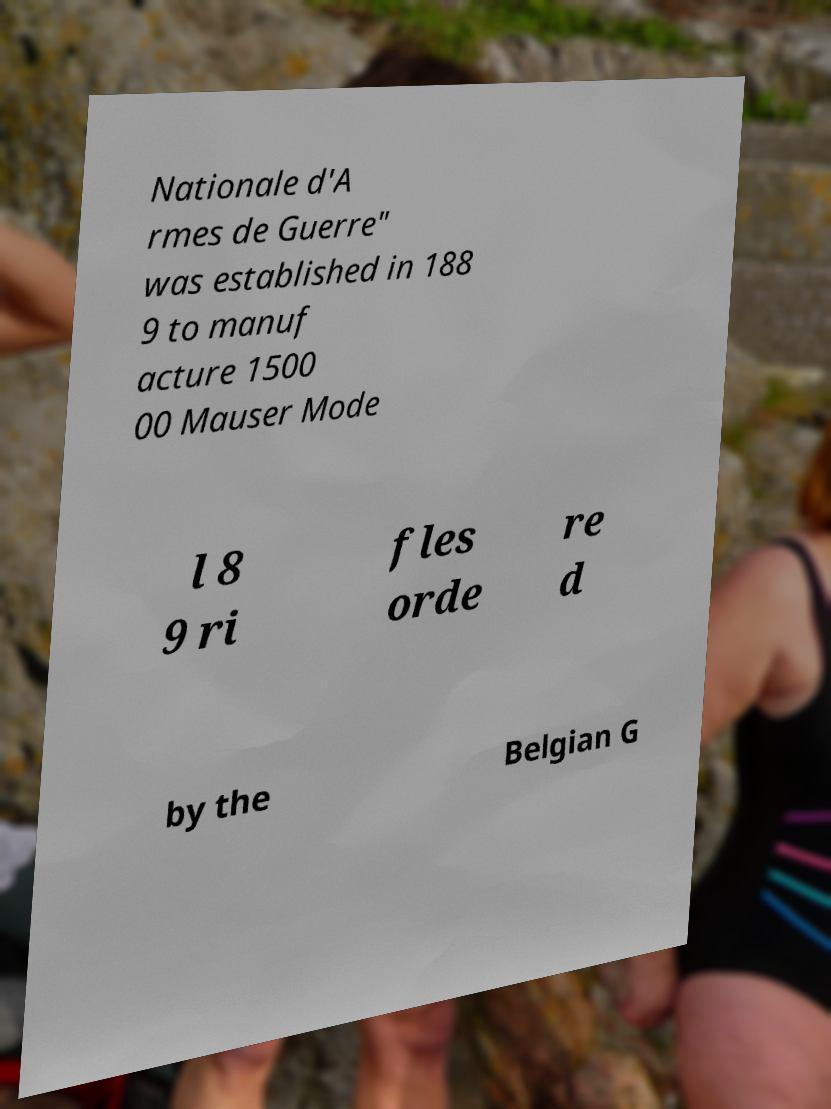I need the written content from this picture converted into text. Can you do that? Nationale d'A rmes de Guerre" was established in 188 9 to manuf acture 1500 00 Mauser Mode l 8 9 ri fles orde re d by the Belgian G 